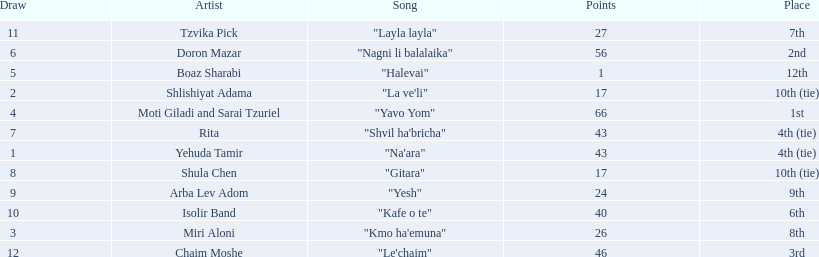What is the place of the contestant who received only 1 point? 12th. What is the name of the artist listed in the previous question? Boaz Sharabi. 